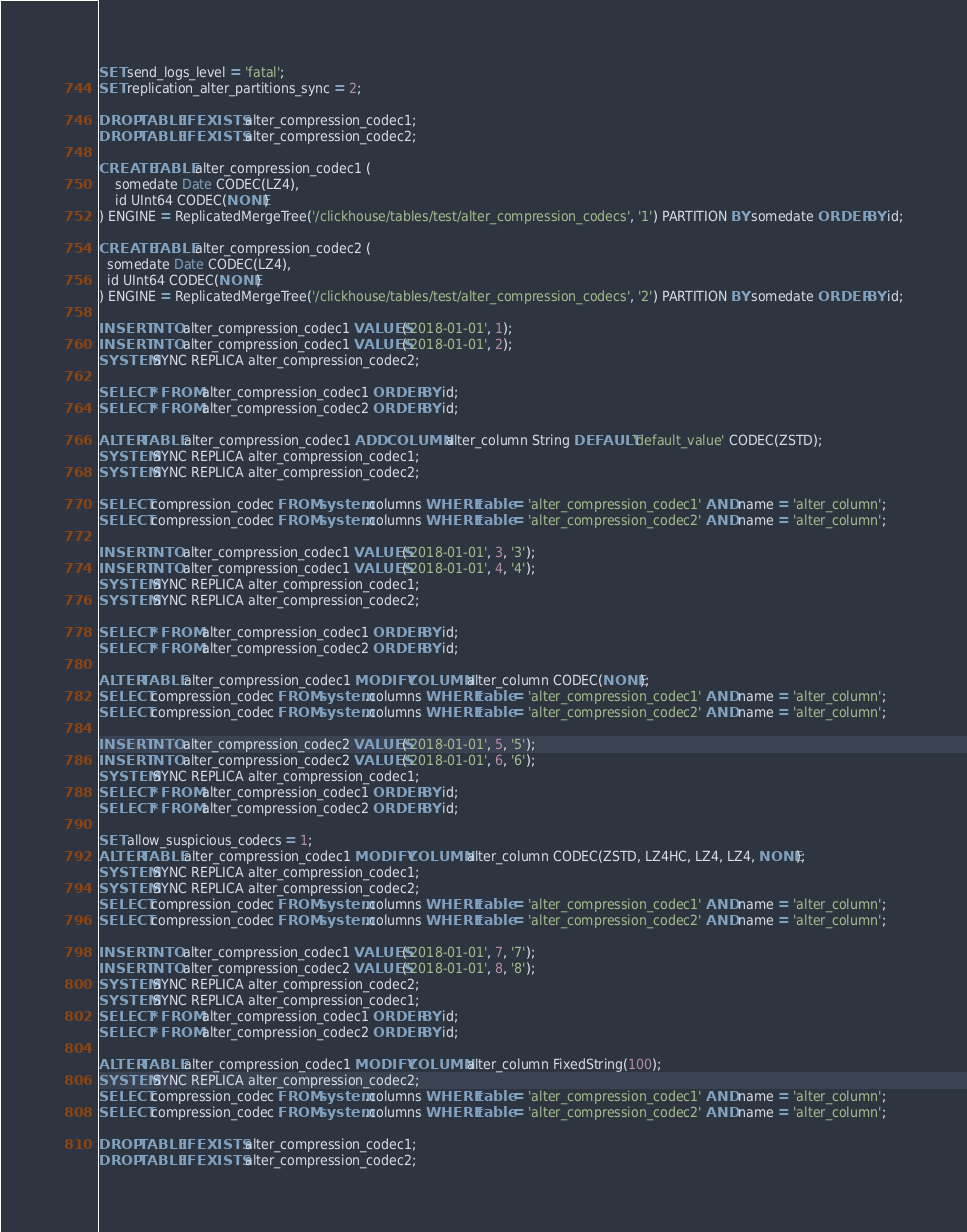<code> <loc_0><loc_0><loc_500><loc_500><_SQL_>SET send_logs_level = 'fatal';
SET replication_alter_partitions_sync = 2;

DROP TABLE IF EXISTS alter_compression_codec1;
DROP TABLE IF EXISTS alter_compression_codec2;

CREATE TABLE alter_compression_codec1 (
    somedate Date CODEC(LZ4),
    id UInt64 CODEC(NONE)
) ENGINE = ReplicatedMergeTree('/clickhouse/tables/test/alter_compression_codecs', '1') PARTITION BY somedate ORDER BY id;

CREATE TABLE alter_compression_codec2 (
  somedate Date CODEC(LZ4),
  id UInt64 CODEC(NONE)
) ENGINE = ReplicatedMergeTree('/clickhouse/tables/test/alter_compression_codecs', '2') PARTITION BY somedate ORDER BY id;

INSERT INTO alter_compression_codec1 VALUES('2018-01-01', 1);
INSERT INTO alter_compression_codec1 VALUES('2018-01-01', 2);
SYSTEM SYNC REPLICA alter_compression_codec2;

SELECT * FROM alter_compression_codec1 ORDER BY id;
SELECT * FROM alter_compression_codec2 ORDER BY id;

ALTER TABLE alter_compression_codec1 ADD COLUMN alter_column String DEFAULT 'default_value' CODEC(ZSTD);
SYSTEM SYNC REPLICA alter_compression_codec1;
SYSTEM SYNC REPLICA alter_compression_codec2;

SELECT compression_codec FROM system.columns WHERE table = 'alter_compression_codec1' AND name = 'alter_column';
SELECT compression_codec FROM system.columns WHERE table = 'alter_compression_codec2' AND name = 'alter_column';

INSERT INTO alter_compression_codec1 VALUES('2018-01-01', 3, '3');
INSERT INTO alter_compression_codec1 VALUES('2018-01-01', 4, '4');
SYSTEM SYNC REPLICA alter_compression_codec1;
SYSTEM SYNC REPLICA alter_compression_codec2;

SELECT * FROM alter_compression_codec1 ORDER BY id;
SELECT * FROM alter_compression_codec2 ORDER BY id;

ALTER TABLE alter_compression_codec1 MODIFY COLUMN alter_column CODEC(NONE);
SELECT compression_codec FROM system.columns WHERE table = 'alter_compression_codec1' AND name = 'alter_column';
SELECT compression_codec FROM system.columns WHERE table = 'alter_compression_codec2' AND name = 'alter_column';

INSERT INTO alter_compression_codec2 VALUES('2018-01-01', 5, '5');
INSERT INTO alter_compression_codec2 VALUES('2018-01-01', 6, '6');
SYSTEM SYNC REPLICA alter_compression_codec1;
SELECT * FROM alter_compression_codec1 ORDER BY id;
SELECT * FROM alter_compression_codec2 ORDER BY id;

SET allow_suspicious_codecs = 1;
ALTER TABLE alter_compression_codec1 MODIFY COLUMN alter_column CODEC(ZSTD, LZ4HC, LZ4, LZ4, NONE);
SYSTEM SYNC REPLICA alter_compression_codec1;
SYSTEM SYNC REPLICA alter_compression_codec2;
SELECT compression_codec FROM system.columns WHERE table = 'alter_compression_codec1' AND name = 'alter_column';
SELECT compression_codec FROM system.columns WHERE table = 'alter_compression_codec2' AND name = 'alter_column';

INSERT INTO alter_compression_codec1 VALUES('2018-01-01', 7, '7');
INSERT INTO alter_compression_codec2 VALUES('2018-01-01', 8, '8');
SYSTEM SYNC REPLICA alter_compression_codec2;
SYSTEM SYNC REPLICA alter_compression_codec1;
SELECT * FROM alter_compression_codec1 ORDER BY id;
SELECT * FROM alter_compression_codec2 ORDER BY id;

ALTER TABLE alter_compression_codec1 MODIFY COLUMN alter_column FixedString(100);
SYSTEM SYNC REPLICA alter_compression_codec2;
SELECT compression_codec FROM system.columns WHERE table = 'alter_compression_codec1' AND name = 'alter_column';
SELECT compression_codec FROM system.columns WHERE table = 'alter_compression_codec2' AND name = 'alter_column';

DROP TABLE IF EXISTS alter_compression_codec1;
DROP TABLE IF EXISTS alter_compression_codec2;
</code> 